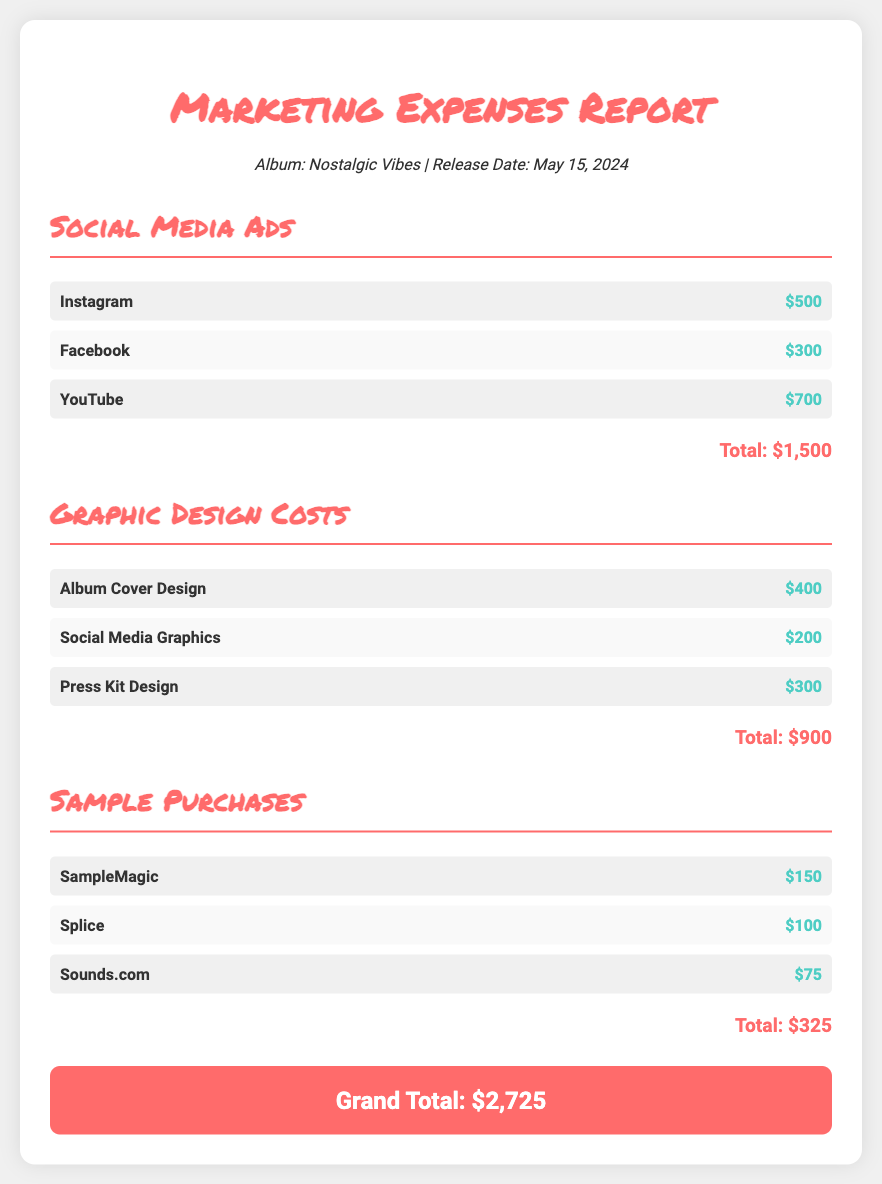What is the album title? The album title is mentioned at the beginning of the document under "Album:" which is "Nostalgic Vibes."
Answer: Nostalgic Vibes When is the album release date? The release date is provided in the release information section, stated as "May 15, 2024."
Answer: May 15, 2024 What is the total amount spent on social media ads? The total amount for social media ads is the sum calculated in the section, which is $500 + $300 + $700 = $1500.
Answer: $1500 How much was spent on graphic design for the album cover? The cost for the album cover design is explicitly listed in the graphic design costs section as $400.
Answer: $400 What is the total amount spent on sample purchases? Total sample purchases is shown in the document as the sum of all individual sample costs, which is $150 + $100 + $75 = $325.
Answer: $325 What is the grand total of all marketing expenses? The grand total is summarized at the end of the document, calculated from all expense sections, amounting to $2725.
Answer: $2725 Which social media platform had the highest advertising expense? The highest expense among social media ads is mentioned for YouTube, which is $700.
Answer: YouTube How much was allocated for the social media graphics design? The cost allocated specifically for social media graphics is listed as $200 in the graphic design costs section.
Answer: $200 What was the expense for sample purchases from Splice? The document states that the purchase from Splice costs $100.
Answer: $100 